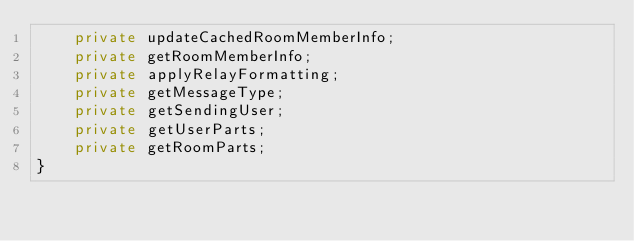Convert code to text. <code><loc_0><loc_0><loc_500><loc_500><_TypeScript_>    private updateCachedRoomMemberInfo;
    private getRoomMemberInfo;
    private applyRelayFormatting;
    private getMessageType;
    private getSendingUser;
    private getUserParts;
    private getRoomParts;
}
</code> 